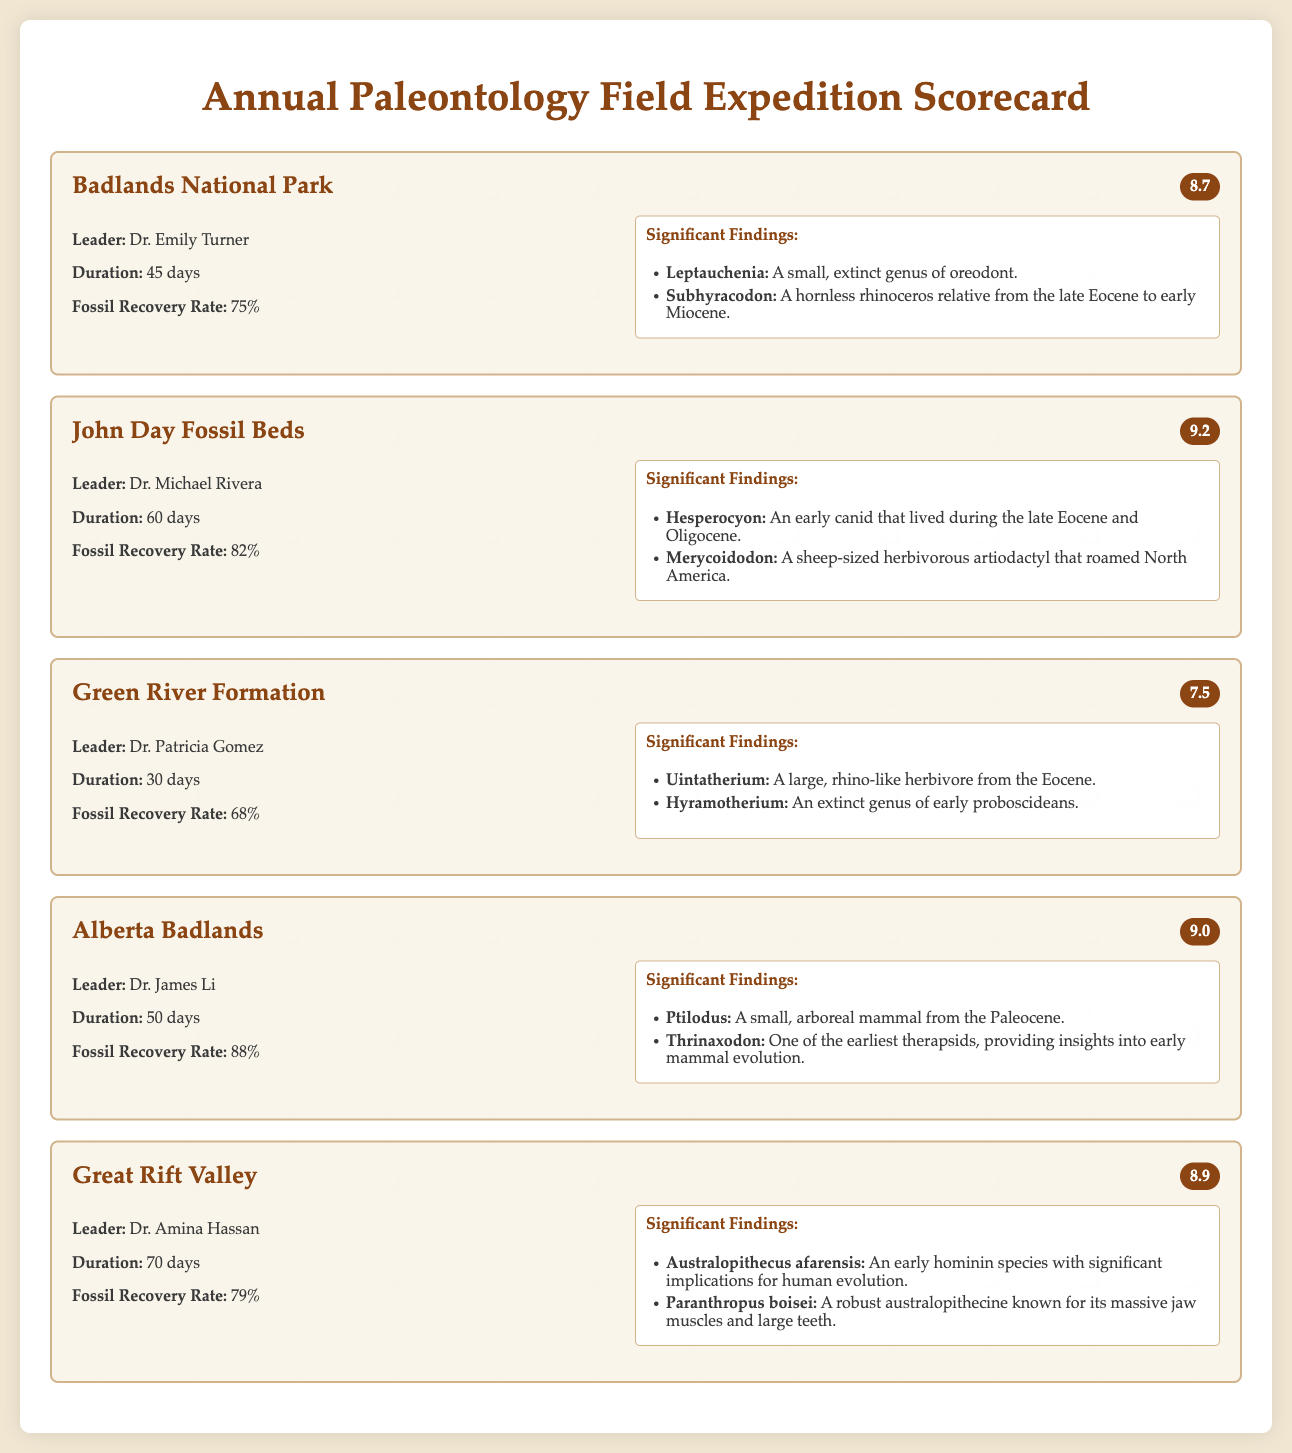What is the leader of the John Day Fossil Beds expedition? The document lists Dr. Michael Rivera as the leader of the John Day Fossil Beds expedition.
Answer: Dr. Michael Rivera What is the fossil recovery rate for Alberta Badlands? The fossil recovery rate for Alberta Badlands is stated in the document as 88%.
Answer: 88% How many days did the Great Rift Valley expedition last? The document mentions that the Great Rift Valley expedition lasted for 70 days.
Answer: 70 days Which expedition has the highest success score? By comparing the success scores mentioned in the document, it’s determined that John Day Fossil Beds has the highest success score of 9.2.
Answer: 9.2 What significant finding was reported from the Green River Formation? The document lists Uintatherium as a significant finding from the Green River Formation.
Answer: Uintatherium Which expeditions had a fossil recovery rate greater than 80%? By examining the fossil recovery rates in the document, Alberta Badlands and John Day Fossil Beds had rates greater than 80%.
Answer: Alberta Badlands, John Day Fossil Beds What is the average success score of all expeditions listed in the scorecard? To find the average, calculate the total success scores (8.7 + 9.2 + 7.5 + 9.0 + 8.9) and divide by the number of expeditions (5). The average is thus 8.66.
Answer: 8.66 How many significant findings are listed for the Badlands National Park expedition? The document states that there are two significant findings listed for the Badlands National Park expedition.
Answer: 2 Who led the Green River Formation expedition? The document states that the expedition was led by Dr. Patricia Gomez.
Answer: Dr. Patricia Gomez 